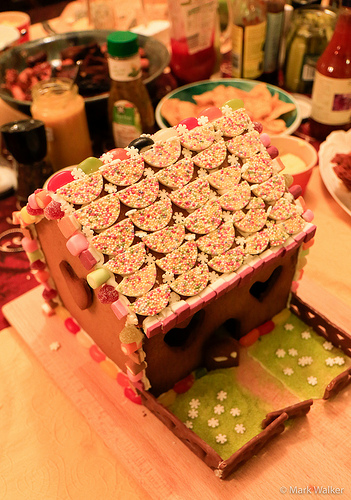<image>
Is there a ketchup next to the bowl? Yes. The ketchup is positioned adjacent to the bowl, located nearby in the same general area. 